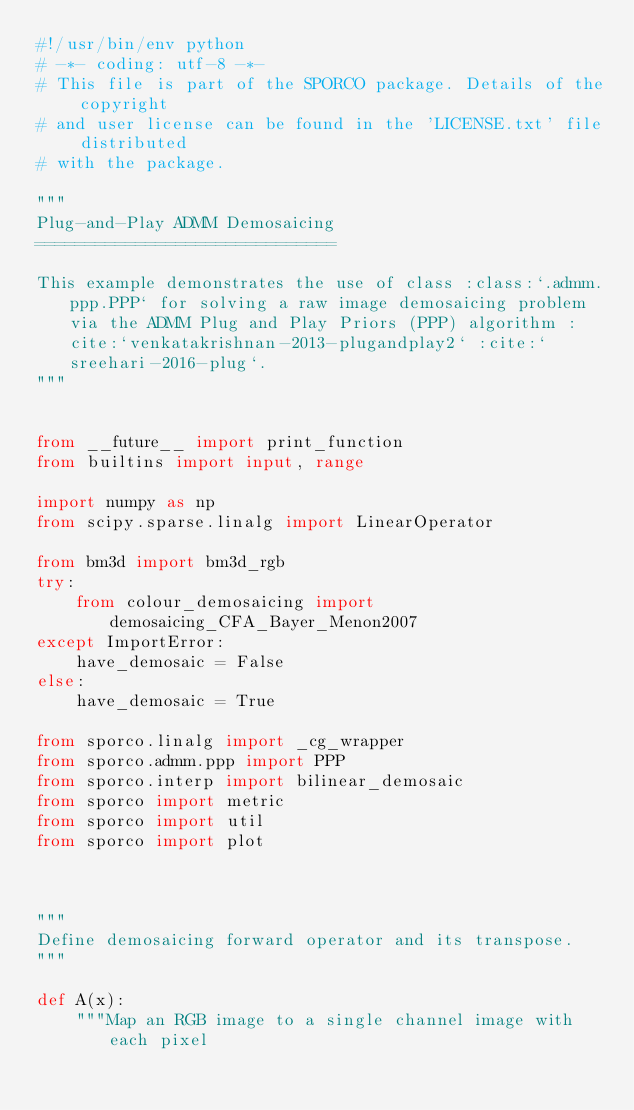Convert code to text. <code><loc_0><loc_0><loc_500><loc_500><_Python_>#!/usr/bin/env python
# -*- coding: utf-8 -*-
# This file is part of the SPORCO package. Details of the copyright
# and user license can be found in the 'LICENSE.txt' file distributed
# with the package.

"""
Plug-and-Play ADMM Demosaicing
==============================

This example demonstrates the use of class :class:`.admm.ppp.PPP` for solving a raw image demosaicing problem via the ADMM Plug and Play Priors (PPP) algorithm :cite:`venkatakrishnan-2013-plugandplay2` :cite:`sreehari-2016-plug`.
"""


from __future__ import print_function
from builtins import input, range

import numpy as np
from scipy.sparse.linalg import LinearOperator

from bm3d import bm3d_rgb
try:
    from colour_demosaicing import demosaicing_CFA_Bayer_Menon2007
except ImportError:
    have_demosaic = False
else:
    have_demosaic = True

from sporco.linalg import _cg_wrapper
from sporco.admm.ppp import PPP
from sporco.interp import bilinear_demosaic
from sporco import metric
from sporco import util
from sporco import plot



"""
Define demosaicing forward operator and its transpose.
"""

def A(x):
    """Map an RGB image to a single channel image with each pixel</code> 